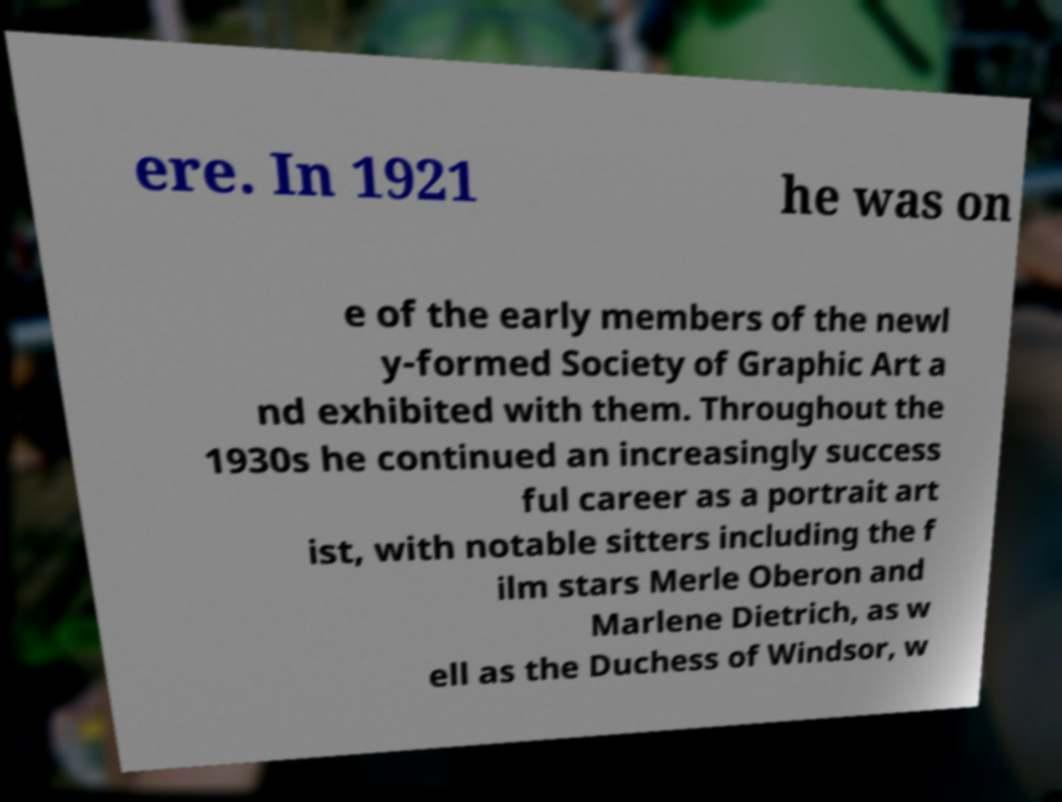What messages or text are displayed in this image? I need them in a readable, typed format. ere. In 1921 he was on e of the early members of the newl y-formed Society of Graphic Art a nd exhibited with them. Throughout the 1930s he continued an increasingly success ful career as a portrait art ist, with notable sitters including the f ilm stars Merle Oberon and Marlene Dietrich, as w ell as the Duchess of Windsor, w 